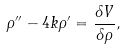<formula> <loc_0><loc_0><loc_500><loc_500>\rho ^ { \prime \prime } - 4 k \rho ^ { \prime } = { \frac { \delta V } { \delta \rho } } ,</formula> 